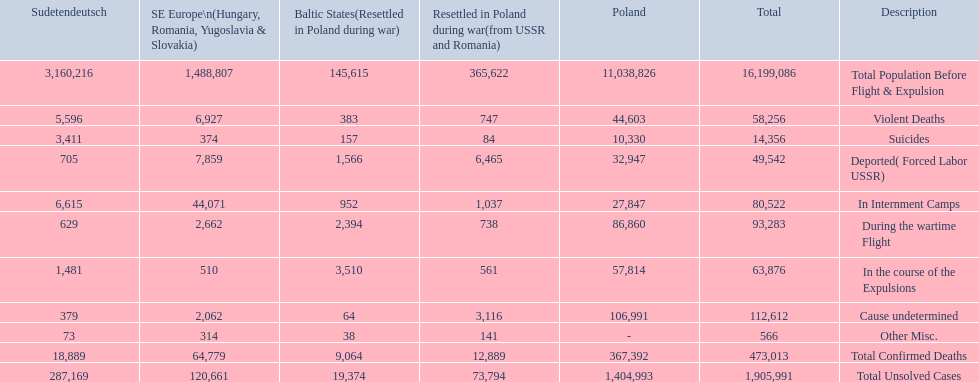What were the total number of confirmed deaths? 473,013. Of these, how many were violent? 58,256. 